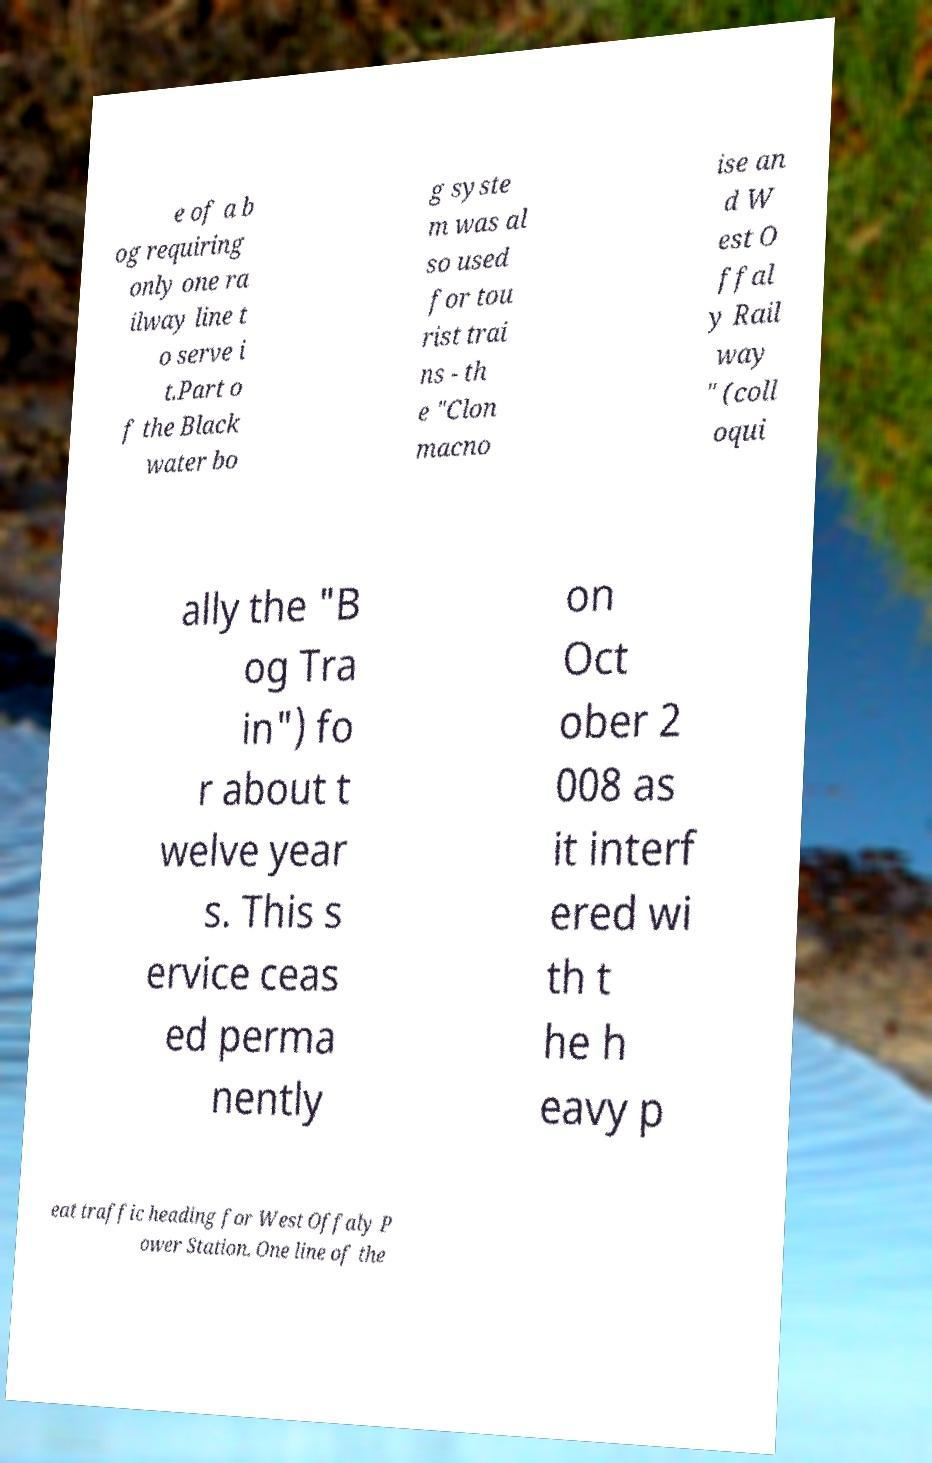What messages or text are displayed in this image? I need them in a readable, typed format. e of a b og requiring only one ra ilway line t o serve i t.Part o f the Black water bo g syste m was al so used for tou rist trai ns - th e "Clon macno ise an d W est O ffal y Rail way " (coll oqui ally the "B og Tra in") fo r about t welve year s. This s ervice ceas ed perma nently on Oct ober 2 008 as it interf ered wi th t he h eavy p eat traffic heading for West Offaly P ower Station. One line of the 